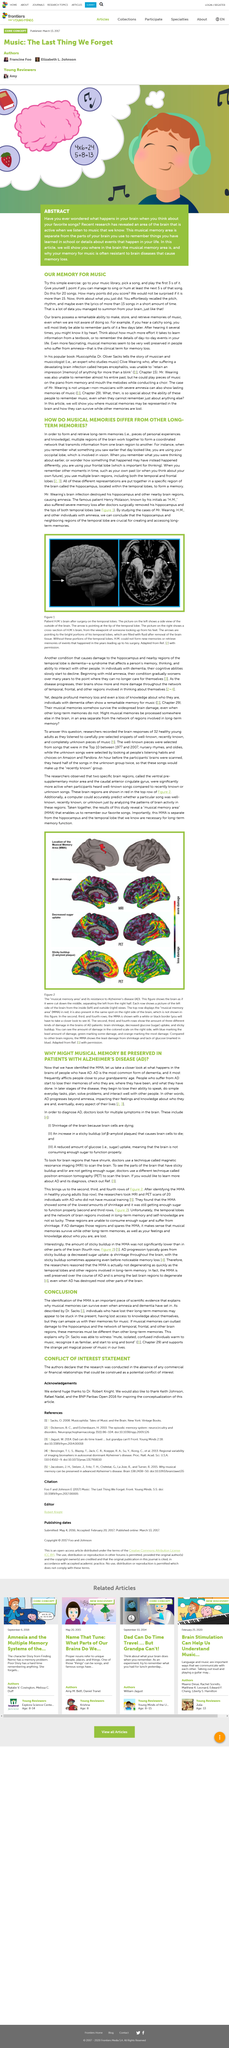Identify some key points in this picture. Yes, the musical memory is distinct from other types of memories, as illustrated in the picture, where the musical part of memory is separated from mathematical memory and other types of memory. Music is often resistant to brain diseases that cause memory loss, making it a powerful tool in preserving memory. The type of memories that can remain intact even when amnesia and dementia have set in are musical memories. Yes, there is a separate part of the brain that is active when we listen to music. Patients with long-term memories may appear stuck in the present and lack access to knowledge about themselves. 